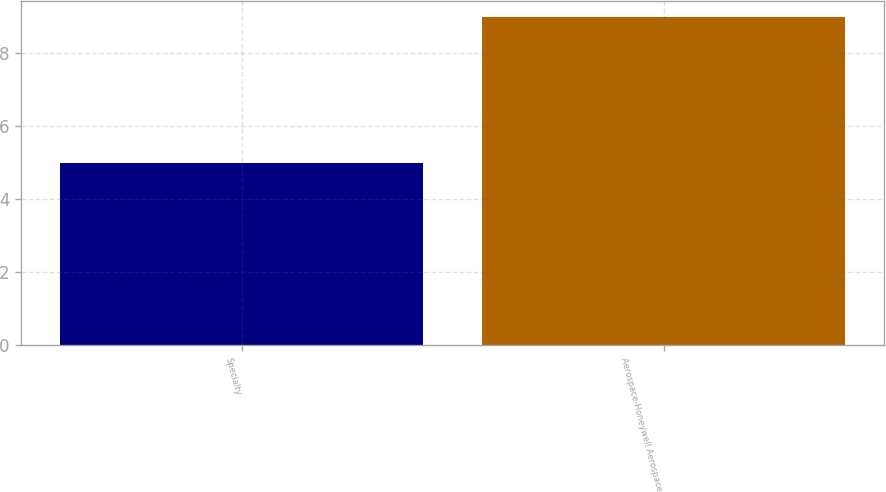Convert chart. <chart><loc_0><loc_0><loc_500><loc_500><bar_chart><fcel>Specialty<fcel>Aerospace-Honeywell Aerospace<nl><fcel>5<fcel>9<nl></chart> 